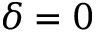Convert formula to latex. <formula><loc_0><loc_0><loc_500><loc_500>\delta = 0</formula> 